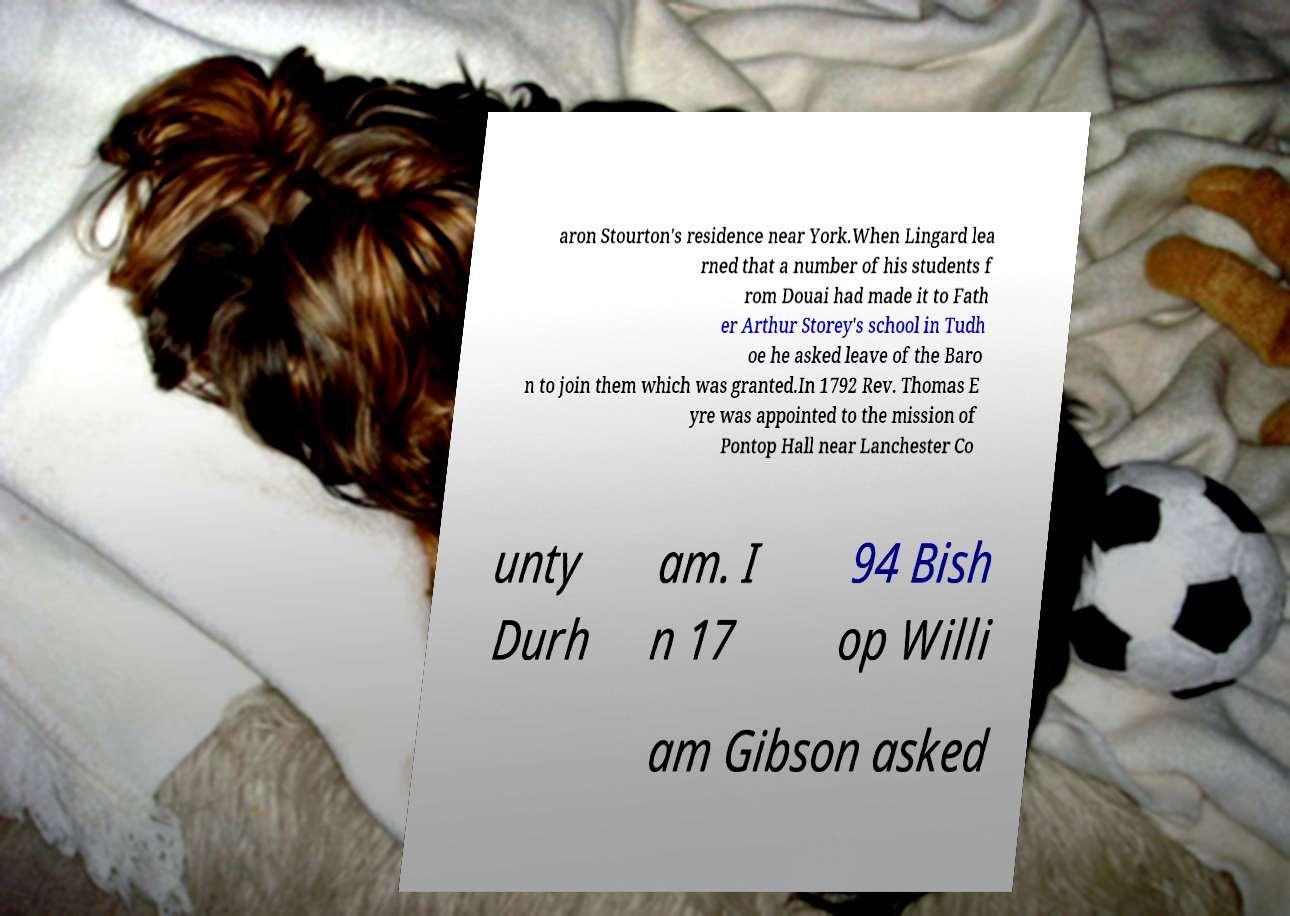Can you read and provide the text displayed in the image?This photo seems to have some interesting text. Can you extract and type it out for me? aron Stourton's residence near York.When Lingard lea rned that a number of his students f rom Douai had made it to Fath er Arthur Storey's school in Tudh oe he asked leave of the Baro n to join them which was granted.In 1792 Rev. Thomas E yre was appointed to the mission of Pontop Hall near Lanchester Co unty Durh am. I n 17 94 Bish op Willi am Gibson asked 